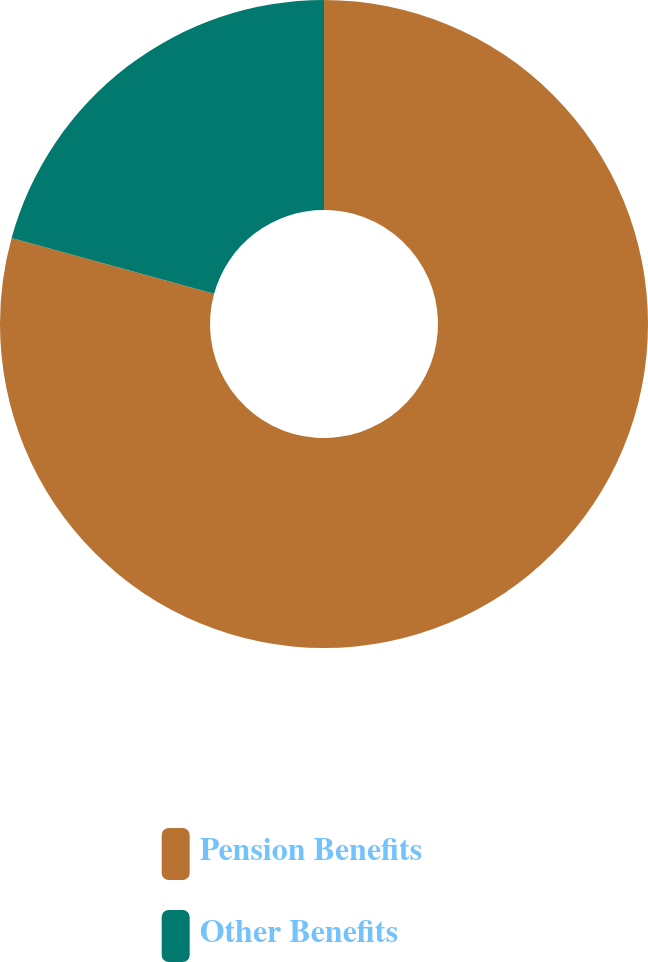Convert chart. <chart><loc_0><loc_0><loc_500><loc_500><pie_chart><fcel>Pension Benefits<fcel>Other Benefits<nl><fcel>79.27%<fcel>20.73%<nl></chart> 